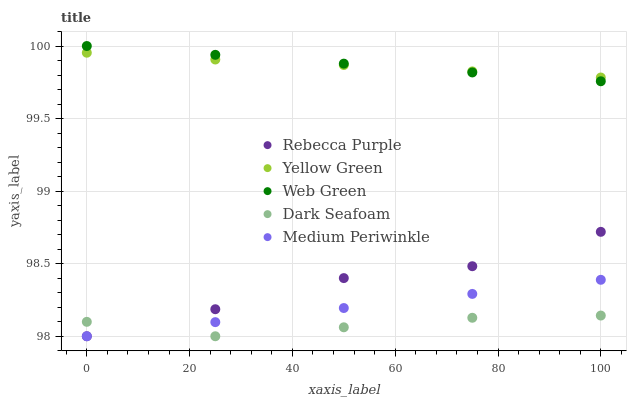Does Dark Seafoam have the minimum area under the curve?
Answer yes or no. Yes. Does Web Green have the maximum area under the curve?
Answer yes or no. Yes. Does Medium Periwinkle have the minimum area under the curve?
Answer yes or no. No. Does Medium Periwinkle have the maximum area under the curve?
Answer yes or no. No. Is Medium Periwinkle the smoothest?
Answer yes or no. Yes. Is Rebecca Purple the roughest?
Answer yes or no. Yes. Is Rebecca Purple the smoothest?
Answer yes or no. No. Is Medium Periwinkle the roughest?
Answer yes or no. No. Does Dark Seafoam have the lowest value?
Answer yes or no. Yes. Does Web Green have the lowest value?
Answer yes or no. No. Does Web Green have the highest value?
Answer yes or no. Yes. Does Medium Periwinkle have the highest value?
Answer yes or no. No. Is Medium Periwinkle less than Yellow Green?
Answer yes or no. Yes. Is Web Green greater than Rebecca Purple?
Answer yes or no. Yes. Does Medium Periwinkle intersect Dark Seafoam?
Answer yes or no. Yes. Is Medium Periwinkle less than Dark Seafoam?
Answer yes or no. No. Is Medium Periwinkle greater than Dark Seafoam?
Answer yes or no. No. Does Medium Periwinkle intersect Yellow Green?
Answer yes or no. No. 